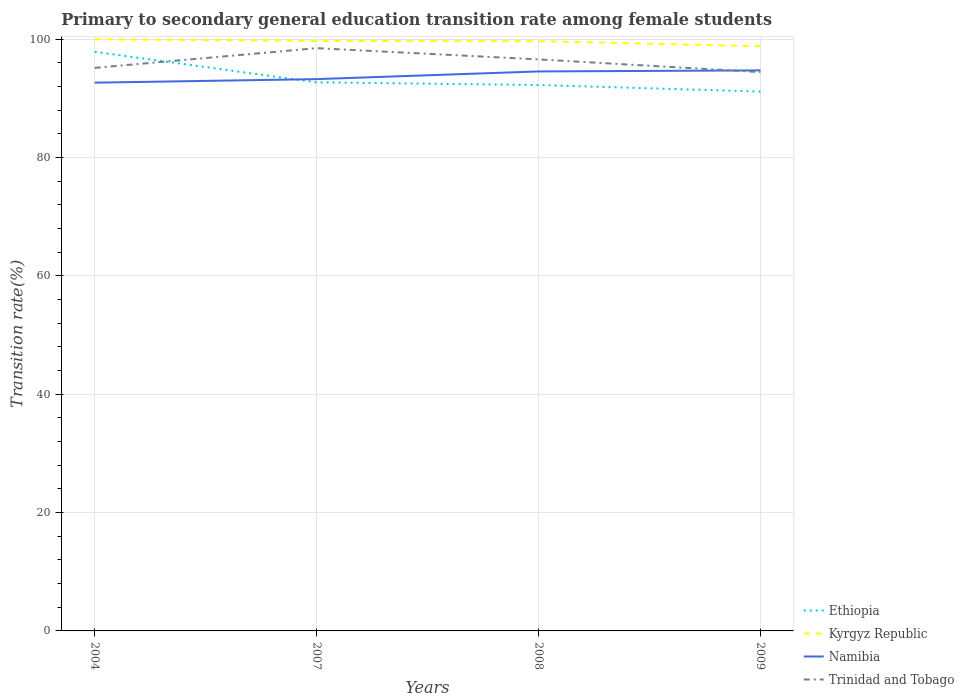Does the line corresponding to Trinidad and Tobago intersect with the line corresponding to Ethiopia?
Give a very brief answer. Yes. Across all years, what is the maximum transition rate in Namibia?
Give a very brief answer. 92.65. What is the total transition rate in Kyrgyz Republic in the graph?
Your answer should be compact. 0.04. What is the difference between the highest and the second highest transition rate in Kyrgyz Republic?
Provide a succinct answer. 1.18. Is the transition rate in Namibia strictly greater than the transition rate in Kyrgyz Republic over the years?
Provide a succinct answer. Yes. How many lines are there?
Provide a short and direct response. 4. What is the difference between two consecutive major ticks on the Y-axis?
Offer a terse response. 20. How many legend labels are there?
Keep it short and to the point. 4. How are the legend labels stacked?
Provide a short and direct response. Vertical. What is the title of the graph?
Make the answer very short. Primary to secondary general education transition rate among female students. Does "Myanmar" appear as one of the legend labels in the graph?
Your answer should be compact. No. What is the label or title of the X-axis?
Make the answer very short. Years. What is the label or title of the Y-axis?
Offer a terse response. Transition rate(%). What is the Transition rate(%) in Ethiopia in 2004?
Your answer should be very brief. 97.87. What is the Transition rate(%) of Kyrgyz Republic in 2004?
Offer a terse response. 100. What is the Transition rate(%) in Namibia in 2004?
Your response must be concise. 92.65. What is the Transition rate(%) of Trinidad and Tobago in 2004?
Your answer should be compact. 95.15. What is the Transition rate(%) of Ethiopia in 2007?
Give a very brief answer. 92.71. What is the Transition rate(%) of Kyrgyz Republic in 2007?
Ensure brevity in your answer.  99.7. What is the Transition rate(%) of Namibia in 2007?
Your answer should be compact. 93.25. What is the Transition rate(%) in Trinidad and Tobago in 2007?
Your answer should be compact. 98.48. What is the Transition rate(%) in Ethiopia in 2008?
Offer a very short reply. 92.26. What is the Transition rate(%) of Kyrgyz Republic in 2008?
Give a very brief answer. 99.67. What is the Transition rate(%) in Namibia in 2008?
Offer a terse response. 94.55. What is the Transition rate(%) of Trinidad and Tobago in 2008?
Provide a short and direct response. 96.58. What is the Transition rate(%) of Ethiopia in 2009?
Keep it short and to the point. 91.15. What is the Transition rate(%) of Kyrgyz Republic in 2009?
Your answer should be compact. 98.82. What is the Transition rate(%) in Namibia in 2009?
Ensure brevity in your answer.  94.73. What is the Transition rate(%) in Trinidad and Tobago in 2009?
Offer a terse response. 94.44. Across all years, what is the maximum Transition rate(%) of Ethiopia?
Offer a terse response. 97.87. Across all years, what is the maximum Transition rate(%) in Namibia?
Offer a very short reply. 94.73. Across all years, what is the maximum Transition rate(%) of Trinidad and Tobago?
Give a very brief answer. 98.48. Across all years, what is the minimum Transition rate(%) of Ethiopia?
Give a very brief answer. 91.15. Across all years, what is the minimum Transition rate(%) of Kyrgyz Republic?
Your answer should be very brief. 98.82. Across all years, what is the minimum Transition rate(%) in Namibia?
Provide a succinct answer. 92.65. Across all years, what is the minimum Transition rate(%) in Trinidad and Tobago?
Give a very brief answer. 94.44. What is the total Transition rate(%) of Ethiopia in the graph?
Your answer should be compact. 373.98. What is the total Transition rate(%) in Kyrgyz Republic in the graph?
Provide a short and direct response. 398.18. What is the total Transition rate(%) of Namibia in the graph?
Your answer should be very brief. 375.18. What is the total Transition rate(%) in Trinidad and Tobago in the graph?
Your answer should be very brief. 384.66. What is the difference between the Transition rate(%) of Ethiopia in 2004 and that in 2007?
Your response must be concise. 5.16. What is the difference between the Transition rate(%) in Kyrgyz Republic in 2004 and that in 2007?
Provide a succinct answer. 0.3. What is the difference between the Transition rate(%) in Namibia in 2004 and that in 2007?
Offer a terse response. -0.6. What is the difference between the Transition rate(%) in Trinidad and Tobago in 2004 and that in 2007?
Keep it short and to the point. -3.33. What is the difference between the Transition rate(%) of Ethiopia in 2004 and that in 2008?
Provide a short and direct response. 5.61. What is the difference between the Transition rate(%) in Kyrgyz Republic in 2004 and that in 2008?
Your answer should be compact. 0.33. What is the difference between the Transition rate(%) of Namibia in 2004 and that in 2008?
Your answer should be compact. -1.9. What is the difference between the Transition rate(%) of Trinidad and Tobago in 2004 and that in 2008?
Offer a very short reply. -1.43. What is the difference between the Transition rate(%) in Ethiopia in 2004 and that in 2009?
Make the answer very short. 6.72. What is the difference between the Transition rate(%) of Kyrgyz Republic in 2004 and that in 2009?
Your answer should be very brief. 1.18. What is the difference between the Transition rate(%) in Namibia in 2004 and that in 2009?
Your answer should be very brief. -2.08. What is the difference between the Transition rate(%) of Trinidad and Tobago in 2004 and that in 2009?
Give a very brief answer. 0.71. What is the difference between the Transition rate(%) of Ethiopia in 2007 and that in 2008?
Provide a succinct answer. 0.45. What is the difference between the Transition rate(%) in Kyrgyz Republic in 2007 and that in 2008?
Keep it short and to the point. 0.04. What is the difference between the Transition rate(%) in Namibia in 2007 and that in 2008?
Ensure brevity in your answer.  -1.3. What is the difference between the Transition rate(%) of Trinidad and Tobago in 2007 and that in 2008?
Ensure brevity in your answer.  1.9. What is the difference between the Transition rate(%) of Ethiopia in 2007 and that in 2009?
Ensure brevity in your answer.  1.56. What is the difference between the Transition rate(%) in Kyrgyz Republic in 2007 and that in 2009?
Keep it short and to the point. 0.89. What is the difference between the Transition rate(%) of Namibia in 2007 and that in 2009?
Provide a short and direct response. -1.48. What is the difference between the Transition rate(%) of Trinidad and Tobago in 2007 and that in 2009?
Your answer should be very brief. 4.05. What is the difference between the Transition rate(%) of Ethiopia in 2008 and that in 2009?
Your answer should be very brief. 1.11. What is the difference between the Transition rate(%) of Kyrgyz Republic in 2008 and that in 2009?
Make the answer very short. 0.85. What is the difference between the Transition rate(%) in Namibia in 2008 and that in 2009?
Your response must be concise. -0.18. What is the difference between the Transition rate(%) of Trinidad and Tobago in 2008 and that in 2009?
Keep it short and to the point. 2.15. What is the difference between the Transition rate(%) in Ethiopia in 2004 and the Transition rate(%) in Kyrgyz Republic in 2007?
Your response must be concise. -1.83. What is the difference between the Transition rate(%) in Ethiopia in 2004 and the Transition rate(%) in Namibia in 2007?
Ensure brevity in your answer.  4.62. What is the difference between the Transition rate(%) in Ethiopia in 2004 and the Transition rate(%) in Trinidad and Tobago in 2007?
Ensure brevity in your answer.  -0.61. What is the difference between the Transition rate(%) in Kyrgyz Republic in 2004 and the Transition rate(%) in Namibia in 2007?
Your answer should be compact. 6.75. What is the difference between the Transition rate(%) in Kyrgyz Republic in 2004 and the Transition rate(%) in Trinidad and Tobago in 2007?
Your answer should be compact. 1.52. What is the difference between the Transition rate(%) of Namibia in 2004 and the Transition rate(%) of Trinidad and Tobago in 2007?
Ensure brevity in your answer.  -5.83. What is the difference between the Transition rate(%) in Ethiopia in 2004 and the Transition rate(%) in Kyrgyz Republic in 2008?
Provide a short and direct response. -1.8. What is the difference between the Transition rate(%) of Ethiopia in 2004 and the Transition rate(%) of Namibia in 2008?
Offer a terse response. 3.32. What is the difference between the Transition rate(%) in Ethiopia in 2004 and the Transition rate(%) in Trinidad and Tobago in 2008?
Offer a terse response. 1.29. What is the difference between the Transition rate(%) in Kyrgyz Republic in 2004 and the Transition rate(%) in Namibia in 2008?
Your answer should be very brief. 5.45. What is the difference between the Transition rate(%) in Kyrgyz Republic in 2004 and the Transition rate(%) in Trinidad and Tobago in 2008?
Offer a very short reply. 3.42. What is the difference between the Transition rate(%) of Namibia in 2004 and the Transition rate(%) of Trinidad and Tobago in 2008?
Your answer should be compact. -3.93. What is the difference between the Transition rate(%) of Ethiopia in 2004 and the Transition rate(%) of Kyrgyz Republic in 2009?
Keep it short and to the point. -0.94. What is the difference between the Transition rate(%) of Ethiopia in 2004 and the Transition rate(%) of Namibia in 2009?
Give a very brief answer. 3.14. What is the difference between the Transition rate(%) in Ethiopia in 2004 and the Transition rate(%) in Trinidad and Tobago in 2009?
Provide a succinct answer. 3.43. What is the difference between the Transition rate(%) of Kyrgyz Republic in 2004 and the Transition rate(%) of Namibia in 2009?
Give a very brief answer. 5.27. What is the difference between the Transition rate(%) in Kyrgyz Republic in 2004 and the Transition rate(%) in Trinidad and Tobago in 2009?
Your response must be concise. 5.56. What is the difference between the Transition rate(%) of Namibia in 2004 and the Transition rate(%) of Trinidad and Tobago in 2009?
Your answer should be very brief. -1.79. What is the difference between the Transition rate(%) of Ethiopia in 2007 and the Transition rate(%) of Kyrgyz Republic in 2008?
Provide a succinct answer. -6.96. What is the difference between the Transition rate(%) of Ethiopia in 2007 and the Transition rate(%) of Namibia in 2008?
Ensure brevity in your answer.  -1.84. What is the difference between the Transition rate(%) in Ethiopia in 2007 and the Transition rate(%) in Trinidad and Tobago in 2008?
Make the answer very short. -3.88. What is the difference between the Transition rate(%) in Kyrgyz Republic in 2007 and the Transition rate(%) in Namibia in 2008?
Your response must be concise. 5.15. What is the difference between the Transition rate(%) of Kyrgyz Republic in 2007 and the Transition rate(%) of Trinidad and Tobago in 2008?
Offer a very short reply. 3.12. What is the difference between the Transition rate(%) in Namibia in 2007 and the Transition rate(%) in Trinidad and Tobago in 2008?
Give a very brief answer. -3.33. What is the difference between the Transition rate(%) in Ethiopia in 2007 and the Transition rate(%) in Kyrgyz Republic in 2009?
Your answer should be very brief. -6.11. What is the difference between the Transition rate(%) in Ethiopia in 2007 and the Transition rate(%) in Namibia in 2009?
Your answer should be very brief. -2.02. What is the difference between the Transition rate(%) in Ethiopia in 2007 and the Transition rate(%) in Trinidad and Tobago in 2009?
Keep it short and to the point. -1.73. What is the difference between the Transition rate(%) of Kyrgyz Republic in 2007 and the Transition rate(%) of Namibia in 2009?
Provide a succinct answer. 4.97. What is the difference between the Transition rate(%) in Kyrgyz Republic in 2007 and the Transition rate(%) in Trinidad and Tobago in 2009?
Offer a terse response. 5.26. What is the difference between the Transition rate(%) of Namibia in 2007 and the Transition rate(%) of Trinidad and Tobago in 2009?
Provide a succinct answer. -1.19. What is the difference between the Transition rate(%) in Ethiopia in 2008 and the Transition rate(%) in Kyrgyz Republic in 2009?
Offer a very short reply. -6.56. What is the difference between the Transition rate(%) of Ethiopia in 2008 and the Transition rate(%) of Namibia in 2009?
Keep it short and to the point. -2.47. What is the difference between the Transition rate(%) in Ethiopia in 2008 and the Transition rate(%) in Trinidad and Tobago in 2009?
Your answer should be compact. -2.18. What is the difference between the Transition rate(%) of Kyrgyz Republic in 2008 and the Transition rate(%) of Namibia in 2009?
Ensure brevity in your answer.  4.94. What is the difference between the Transition rate(%) in Kyrgyz Republic in 2008 and the Transition rate(%) in Trinidad and Tobago in 2009?
Your response must be concise. 5.23. What is the difference between the Transition rate(%) in Namibia in 2008 and the Transition rate(%) in Trinidad and Tobago in 2009?
Your answer should be compact. 0.11. What is the average Transition rate(%) in Ethiopia per year?
Your answer should be compact. 93.5. What is the average Transition rate(%) in Kyrgyz Republic per year?
Offer a terse response. 99.55. What is the average Transition rate(%) of Namibia per year?
Ensure brevity in your answer.  93.8. What is the average Transition rate(%) in Trinidad and Tobago per year?
Your response must be concise. 96.17. In the year 2004, what is the difference between the Transition rate(%) of Ethiopia and Transition rate(%) of Kyrgyz Republic?
Provide a short and direct response. -2.13. In the year 2004, what is the difference between the Transition rate(%) in Ethiopia and Transition rate(%) in Namibia?
Your answer should be very brief. 5.22. In the year 2004, what is the difference between the Transition rate(%) in Ethiopia and Transition rate(%) in Trinidad and Tobago?
Offer a terse response. 2.72. In the year 2004, what is the difference between the Transition rate(%) of Kyrgyz Republic and Transition rate(%) of Namibia?
Give a very brief answer. 7.35. In the year 2004, what is the difference between the Transition rate(%) in Kyrgyz Republic and Transition rate(%) in Trinidad and Tobago?
Give a very brief answer. 4.85. In the year 2004, what is the difference between the Transition rate(%) in Namibia and Transition rate(%) in Trinidad and Tobago?
Your answer should be very brief. -2.5. In the year 2007, what is the difference between the Transition rate(%) of Ethiopia and Transition rate(%) of Kyrgyz Republic?
Make the answer very short. -6.99. In the year 2007, what is the difference between the Transition rate(%) of Ethiopia and Transition rate(%) of Namibia?
Ensure brevity in your answer.  -0.54. In the year 2007, what is the difference between the Transition rate(%) of Ethiopia and Transition rate(%) of Trinidad and Tobago?
Offer a terse response. -5.78. In the year 2007, what is the difference between the Transition rate(%) of Kyrgyz Republic and Transition rate(%) of Namibia?
Offer a very short reply. 6.45. In the year 2007, what is the difference between the Transition rate(%) in Kyrgyz Republic and Transition rate(%) in Trinidad and Tobago?
Give a very brief answer. 1.22. In the year 2007, what is the difference between the Transition rate(%) of Namibia and Transition rate(%) of Trinidad and Tobago?
Your answer should be very brief. -5.23. In the year 2008, what is the difference between the Transition rate(%) in Ethiopia and Transition rate(%) in Kyrgyz Republic?
Provide a short and direct response. -7.41. In the year 2008, what is the difference between the Transition rate(%) in Ethiopia and Transition rate(%) in Namibia?
Your response must be concise. -2.29. In the year 2008, what is the difference between the Transition rate(%) of Ethiopia and Transition rate(%) of Trinidad and Tobago?
Give a very brief answer. -4.33. In the year 2008, what is the difference between the Transition rate(%) of Kyrgyz Republic and Transition rate(%) of Namibia?
Provide a short and direct response. 5.12. In the year 2008, what is the difference between the Transition rate(%) of Kyrgyz Republic and Transition rate(%) of Trinidad and Tobago?
Keep it short and to the point. 3.08. In the year 2008, what is the difference between the Transition rate(%) of Namibia and Transition rate(%) of Trinidad and Tobago?
Your answer should be very brief. -2.03. In the year 2009, what is the difference between the Transition rate(%) of Ethiopia and Transition rate(%) of Kyrgyz Republic?
Your answer should be compact. -7.67. In the year 2009, what is the difference between the Transition rate(%) of Ethiopia and Transition rate(%) of Namibia?
Offer a terse response. -3.58. In the year 2009, what is the difference between the Transition rate(%) in Ethiopia and Transition rate(%) in Trinidad and Tobago?
Ensure brevity in your answer.  -3.29. In the year 2009, what is the difference between the Transition rate(%) in Kyrgyz Republic and Transition rate(%) in Namibia?
Provide a succinct answer. 4.09. In the year 2009, what is the difference between the Transition rate(%) in Kyrgyz Republic and Transition rate(%) in Trinidad and Tobago?
Provide a succinct answer. 4.38. In the year 2009, what is the difference between the Transition rate(%) in Namibia and Transition rate(%) in Trinidad and Tobago?
Ensure brevity in your answer.  0.29. What is the ratio of the Transition rate(%) in Ethiopia in 2004 to that in 2007?
Offer a terse response. 1.06. What is the ratio of the Transition rate(%) of Namibia in 2004 to that in 2007?
Your response must be concise. 0.99. What is the ratio of the Transition rate(%) of Trinidad and Tobago in 2004 to that in 2007?
Provide a succinct answer. 0.97. What is the ratio of the Transition rate(%) of Ethiopia in 2004 to that in 2008?
Your answer should be compact. 1.06. What is the ratio of the Transition rate(%) in Kyrgyz Republic in 2004 to that in 2008?
Make the answer very short. 1. What is the ratio of the Transition rate(%) of Namibia in 2004 to that in 2008?
Provide a succinct answer. 0.98. What is the ratio of the Transition rate(%) in Trinidad and Tobago in 2004 to that in 2008?
Your answer should be very brief. 0.99. What is the ratio of the Transition rate(%) of Ethiopia in 2004 to that in 2009?
Offer a terse response. 1.07. What is the ratio of the Transition rate(%) of Namibia in 2004 to that in 2009?
Provide a succinct answer. 0.98. What is the ratio of the Transition rate(%) in Trinidad and Tobago in 2004 to that in 2009?
Make the answer very short. 1.01. What is the ratio of the Transition rate(%) of Ethiopia in 2007 to that in 2008?
Ensure brevity in your answer.  1. What is the ratio of the Transition rate(%) in Namibia in 2007 to that in 2008?
Your answer should be very brief. 0.99. What is the ratio of the Transition rate(%) of Trinidad and Tobago in 2007 to that in 2008?
Keep it short and to the point. 1.02. What is the ratio of the Transition rate(%) in Ethiopia in 2007 to that in 2009?
Offer a very short reply. 1.02. What is the ratio of the Transition rate(%) in Kyrgyz Republic in 2007 to that in 2009?
Make the answer very short. 1.01. What is the ratio of the Transition rate(%) in Namibia in 2007 to that in 2009?
Offer a terse response. 0.98. What is the ratio of the Transition rate(%) in Trinidad and Tobago in 2007 to that in 2009?
Keep it short and to the point. 1.04. What is the ratio of the Transition rate(%) of Ethiopia in 2008 to that in 2009?
Offer a very short reply. 1.01. What is the ratio of the Transition rate(%) in Kyrgyz Republic in 2008 to that in 2009?
Give a very brief answer. 1.01. What is the ratio of the Transition rate(%) of Trinidad and Tobago in 2008 to that in 2009?
Your answer should be compact. 1.02. What is the difference between the highest and the second highest Transition rate(%) in Ethiopia?
Keep it short and to the point. 5.16. What is the difference between the highest and the second highest Transition rate(%) in Kyrgyz Republic?
Provide a succinct answer. 0.3. What is the difference between the highest and the second highest Transition rate(%) of Namibia?
Offer a very short reply. 0.18. What is the difference between the highest and the lowest Transition rate(%) of Ethiopia?
Provide a succinct answer. 6.72. What is the difference between the highest and the lowest Transition rate(%) in Kyrgyz Republic?
Keep it short and to the point. 1.18. What is the difference between the highest and the lowest Transition rate(%) in Namibia?
Your answer should be very brief. 2.08. What is the difference between the highest and the lowest Transition rate(%) in Trinidad and Tobago?
Your answer should be compact. 4.05. 